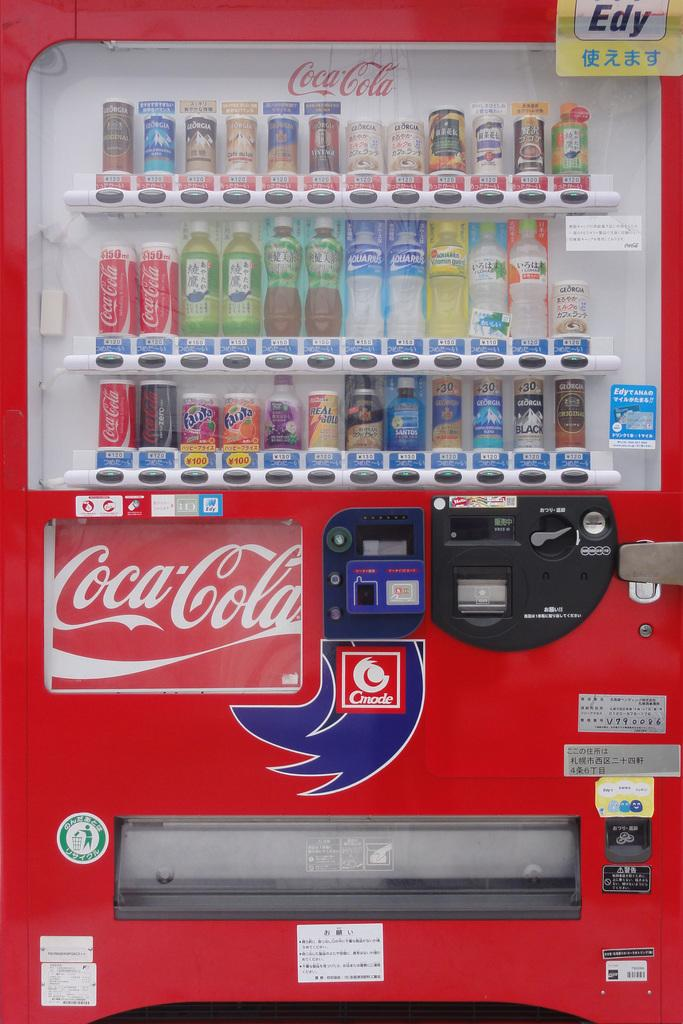Provide a one-sentence caption for the provided image. A coca-cola machine filled with all sorts of coke products to drink. 